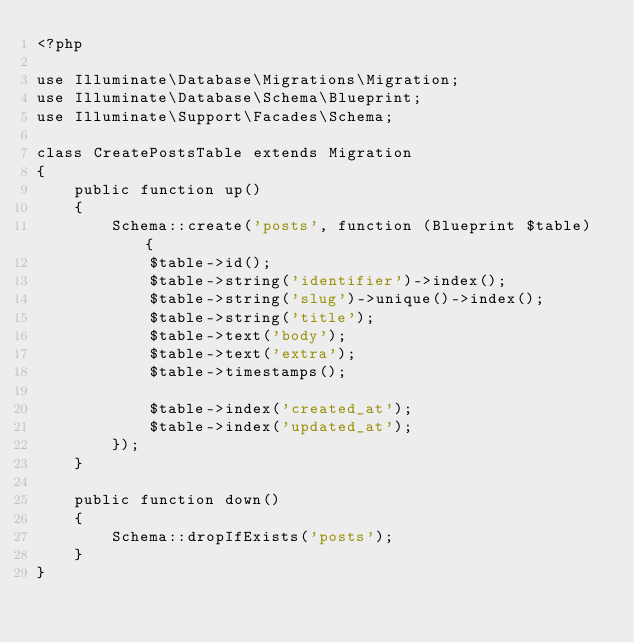Convert code to text. <code><loc_0><loc_0><loc_500><loc_500><_PHP_><?php

use Illuminate\Database\Migrations\Migration;
use Illuminate\Database\Schema\Blueprint;
use Illuminate\Support\Facades\Schema;

class CreatePostsTable extends Migration
{
    public function up()
    {
        Schema::create('posts', function (Blueprint $table) {
            $table->id();
            $table->string('identifier')->index();
            $table->string('slug')->unique()->index();
            $table->string('title');
            $table->text('body');
            $table->text('extra');
            $table->timestamps();

            $table->index('created_at');
            $table->index('updated_at');
        });
    }

    public function down()
    {
        Schema::dropIfExists('posts');
    }
}
</code> 